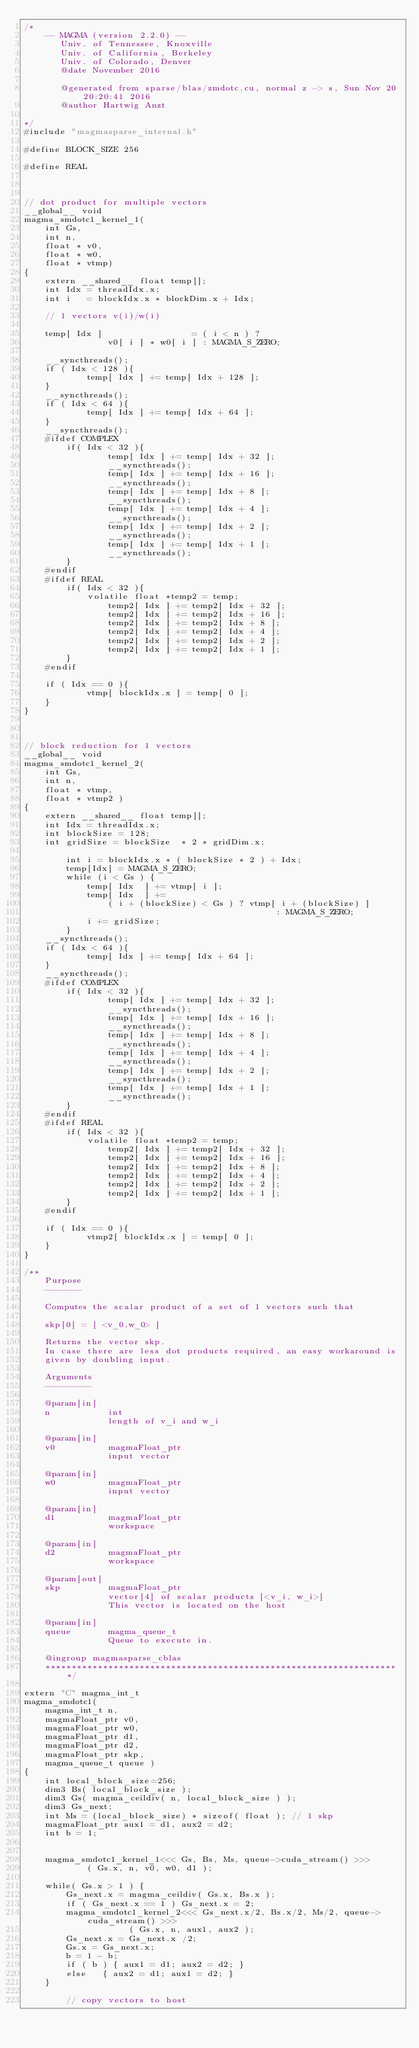<code> <loc_0><loc_0><loc_500><loc_500><_Cuda_>/*
    -- MAGMA (version 2.2.0) --
       Univ. of Tennessee, Knoxville
       Univ. of California, Berkeley
       Univ. of Colorado, Denver
       @date November 2016

       @generated from sparse/blas/zmdotc.cu, normal z -> s, Sun Nov 20 20:20:41 2016
       @author Hartwig Anzt

*/
#include "magmasparse_internal.h"

#define BLOCK_SIZE 256

#define REAL



// dot product for multiple vectors
__global__ void
magma_smdotc1_kernel_1( 
    int Gs,
    int n, 
    float * v0,
    float * w0,
    float * vtmp)
{
    extern __shared__ float temp[]; 
    int Idx = threadIdx.x;   
    int i   = blockIdx.x * blockDim.x + Idx;

    // 1 vectors v(i)/w(i)
    
    temp[ Idx ]                 = ( i < n ) ?
                v0[ i ] * w0[ i ] : MAGMA_S_ZERO;
    
    __syncthreads();
    if ( Idx < 128 ){
            temp[ Idx ] += temp[ Idx + 128 ];
    }
    __syncthreads();
    if ( Idx < 64 ){
            temp[ Idx ] += temp[ Idx + 64 ];
    }
    __syncthreads();
    #ifdef COMPLEX
        if( Idx < 32 ){
                temp[ Idx ] += temp[ Idx + 32 ];
                __syncthreads();
                temp[ Idx ] += temp[ Idx + 16 ];
                __syncthreads();
                temp[ Idx ] += temp[ Idx + 8 ];
                __syncthreads();
                temp[ Idx ] += temp[ Idx + 4 ];
                __syncthreads();
                temp[ Idx ] += temp[ Idx + 2 ];
                __syncthreads();
                temp[ Idx ] += temp[ Idx + 1 ];
                __syncthreads();
        }
    #endif
    #ifdef REAL
        if( Idx < 32 ){
            volatile float *temp2 = temp;
                temp2[ Idx ] += temp2[ Idx + 32 ];
                temp2[ Idx ] += temp2[ Idx + 16 ];
                temp2[ Idx ] += temp2[ Idx + 8 ];
                temp2[ Idx ] += temp2[ Idx + 4 ];
                temp2[ Idx ] += temp2[ Idx + 2 ];
                temp2[ Idx ] += temp2[ Idx + 1 ];
        }
    #endif
    
    if ( Idx == 0 ){
            vtmp[ blockIdx.x ] = temp[ 0 ];
    }
}



// block reduction for 1 vectors
__global__ void
magma_smdotc1_kernel_2( 
    int Gs,
    int n, 
    float * vtmp,
    float * vtmp2 )
{
    extern __shared__ float temp[];    
    int Idx = threadIdx.x;
    int blockSize = 128;
    int gridSize = blockSize  * 2 * gridDim.x; 

        int i = blockIdx.x * ( blockSize * 2 ) + Idx;   
        temp[Idx] = MAGMA_S_ZERO;
        while (i < Gs ) {
            temp[ Idx  ] += vtmp[ i ]; 
            temp[ Idx  ] += 
                ( i + (blockSize) < Gs ) ? vtmp[ i + (blockSize) ] 
                                                : MAGMA_S_ZERO;
            i += gridSize;
        }
    __syncthreads();
    if ( Idx < 64 ){
            temp[ Idx ] += temp[ Idx + 64 ];
    }
    __syncthreads();
    #ifdef COMPLEX
        if( Idx < 32 ){
                temp[ Idx ] += temp[ Idx + 32 ];
                __syncthreads();
                temp[ Idx ] += temp[ Idx + 16 ];
                __syncthreads();
                temp[ Idx ] += temp[ Idx + 8 ];
                __syncthreads();
                temp[ Idx ] += temp[ Idx + 4 ];
                __syncthreads();
                temp[ Idx ] += temp[ Idx + 2 ];
                __syncthreads();
                temp[ Idx ] += temp[ Idx + 1 ];
                __syncthreads();
        }
    #endif
    #ifdef REAL
        if( Idx < 32 ){
            volatile float *temp2 = temp;
                temp2[ Idx ] += temp2[ Idx + 32 ];
                temp2[ Idx ] += temp2[ Idx + 16 ];
                temp2[ Idx ] += temp2[ Idx + 8 ];
                temp2[ Idx ] += temp2[ Idx + 4 ];
                temp2[ Idx ] += temp2[ Idx + 2 ];
                temp2[ Idx ] += temp2[ Idx + 1 ];
        }
    #endif
    
    if ( Idx == 0 ){
            vtmp2[ blockIdx.x ] = temp[ 0 ];
    }
}

/**
    Purpose
    -------

    Computes the scalar product of a set of 1 vectors such that

    skp[0] = [ <v_0,w_0> ]

    Returns the vector skp.
    In case there are less dot products required, an easy workaround is
    given by doubling input.

    Arguments
    ---------

    @param[in]
    n           int
                length of v_i and w_i

    @param[in]                             
    v0          magmaFloat_ptr     
                input vector               

    @param[in]                                         
    w0          magmaFloat_ptr                 
                input vector                           

    @param[in]
    d1          magmaFloat_ptr 
                workspace

    @param[in]
    d2          magmaFloat_ptr 
                workspace

    @param[out]
    skp         magmaFloat_ptr 
                vector[4] of scalar products [<v_i, w_i>]
                This vector is located on the host

    @param[in]
    queue       magma_queue_t
                Queue to execute in.

    @ingroup magmasparse_cblas
    ********************************************************************/

extern "C" magma_int_t
magma_smdotc1(
    magma_int_t n,  
    magmaFloat_ptr v0, 
    magmaFloat_ptr w0,
    magmaFloat_ptr d1,
    magmaFloat_ptr d2,
    magmaFloat_ptr skp,
    magma_queue_t queue )
{
    int local_block_size=256;
    dim3 Bs( local_block_size );
    dim3 Gs( magma_ceildiv( n, local_block_size ) );
    dim3 Gs_next;
    int Ms = (local_block_size) * sizeof( float ); // 1 skp 
    magmaFloat_ptr aux1 = d1, aux2 = d2;
    int b = 1;        


    magma_smdotc1_kernel_1<<< Gs, Bs, Ms, queue->cuda_stream() >>>
            ( Gs.x, n, v0, w0, d1 );
   
    while( Gs.x > 1 ) {
        Gs_next.x = magma_ceildiv( Gs.x, Bs.x );
        if ( Gs_next.x == 1 ) Gs_next.x = 2;
        magma_smdotc1_kernel_2<<< Gs_next.x/2, Bs.x/2, Ms/2, queue->cuda_stream() >>> 
                    ( Gs.x, n, aux1, aux2 );
        Gs_next.x = Gs_next.x /2;
        Gs.x = Gs_next.x;
        b = 1 - b;
        if ( b ) { aux1 = d1; aux2 = d2; }
        else   { aux2 = d1; aux1 = d2; }
    }
    
        // copy vectors to host</code> 